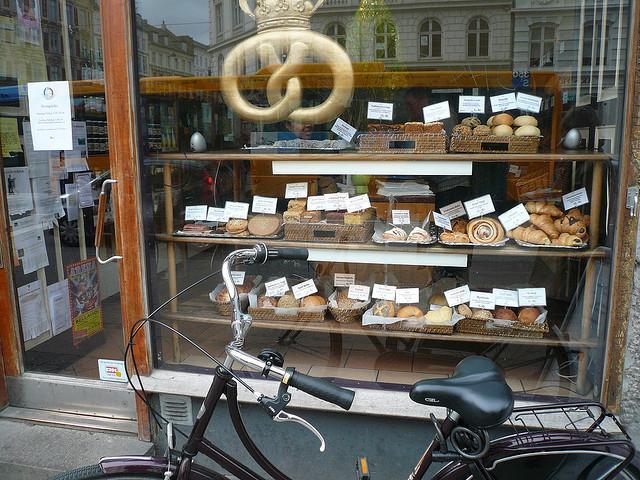What color is painted on the metal frame of the bicycle parked in front of the cake store?
Make your selection from the four choices given to correctly answer the question.
Options: Black, red, pink, green. Black. 